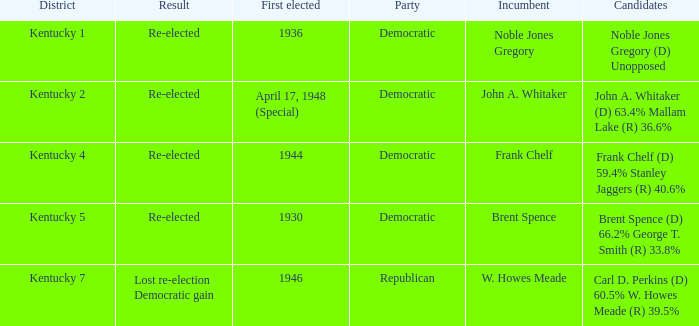List all candidates in the democratic party where the election had the incumbent Frank Chelf running. Frank Chelf (D) 59.4% Stanley Jaggers (R) 40.6%. 